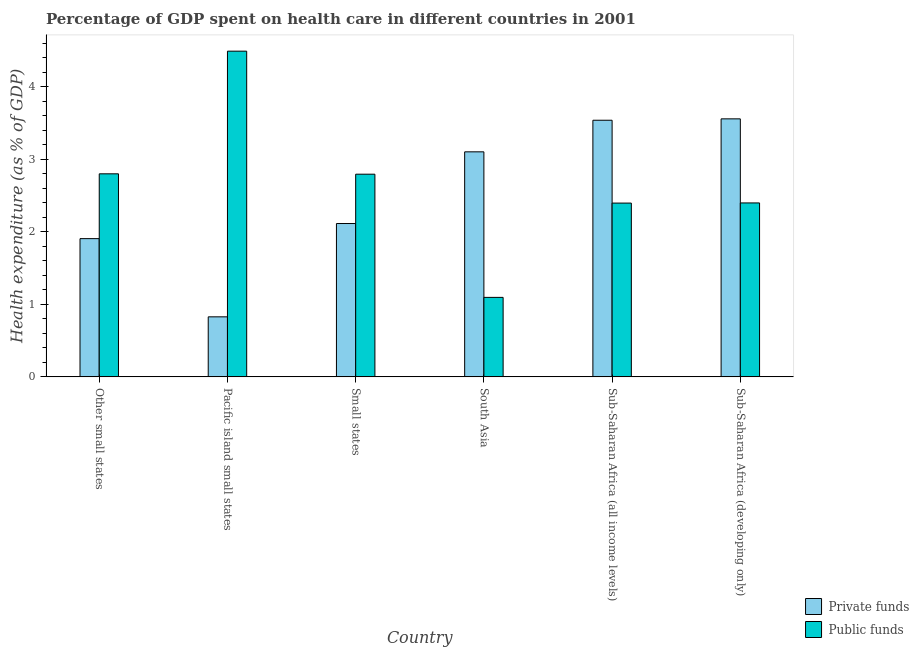How many different coloured bars are there?
Offer a very short reply. 2. How many groups of bars are there?
Your answer should be very brief. 6. Are the number of bars per tick equal to the number of legend labels?
Your answer should be compact. Yes. What is the label of the 2nd group of bars from the left?
Provide a succinct answer. Pacific island small states. In how many cases, is the number of bars for a given country not equal to the number of legend labels?
Make the answer very short. 0. What is the amount of private funds spent in healthcare in Sub-Saharan Africa (all income levels)?
Provide a succinct answer. 3.54. Across all countries, what is the maximum amount of public funds spent in healthcare?
Give a very brief answer. 4.49. Across all countries, what is the minimum amount of public funds spent in healthcare?
Your answer should be compact. 1.1. In which country was the amount of private funds spent in healthcare maximum?
Give a very brief answer. Sub-Saharan Africa (developing only). What is the total amount of private funds spent in healthcare in the graph?
Keep it short and to the point. 15.05. What is the difference between the amount of private funds spent in healthcare in Small states and that in Sub-Saharan Africa (developing only)?
Your answer should be very brief. -1.44. What is the difference between the amount of private funds spent in healthcare in Sub-Saharan Africa (all income levels) and the amount of public funds spent in healthcare in Small states?
Your answer should be very brief. 0.74. What is the average amount of public funds spent in healthcare per country?
Your answer should be compact. 2.66. What is the difference between the amount of private funds spent in healthcare and amount of public funds spent in healthcare in Sub-Saharan Africa (developing only)?
Offer a terse response. 1.16. What is the ratio of the amount of private funds spent in healthcare in Pacific island small states to that in Sub-Saharan Africa (developing only)?
Your answer should be very brief. 0.23. Is the amount of public funds spent in healthcare in Small states less than that in South Asia?
Your response must be concise. No. What is the difference between the highest and the second highest amount of public funds spent in healthcare?
Ensure brevity in your answer.  1.69. What is the difference between the highest and the lowest amount of public funds spent in healthcare?
Give a very brief answer. 3.4. In how many countries, is the amount of private funds spent in healthcare greater than the average amount of private funds spent in healthcare taken over all countries?
Ensure brevity in your answer.  3. What does the 1st bar from the left in Other small states represents?
Ensure brevity in your answer.  Private funds. What does the 2nd bar from the right in Sub-Saharan Africa (developing only) represents?
Your answer should be very brief. Private funds. How many bars are there?
Provide a succinct answer. 12. Are all the bars in the graph horizontal?
Your answer should be very brief. No. How many countries are there in the graph?
Your answer should be very brief. 6. Are the values on the major ticks of Y-axis written in scientific E-notation?
Your answer should be compact. No. How many legend labels are there?
Offer a terse response. 2. What is the title of the graph?
Give a very brief answer. Percentage of GDP spent on health care in different countries in 2001. Does "RDB nonconcessional" appear as one of the legend labels in the graph?
Provide a succinct answer. No. What is the label or title of the X-axis?
Make the answer very short. Country. What is the label or title of the Y-axis?
Your response must be concise. Health expenditure (as % of GDP). What is the Health expenditure (as % of GDP) in Private funds in Other small states?
Keep it short and to the point. 1.91. What is the Health expenditure (as % of GDP) in Public funds in Other small states?
Provide a succinct answer. 2.8. What is the Health expenditure (as % of GDP) in Private funds in Pacific island small states?
Your answer should be very brief. 0.83. What is the Health expenditure (as % of GDP) in Public funds in Pacific island small states?
Your answer should be compact. 4.49. What is the Health expenditure (as % of GDP) of Private funds in Small states?
Ensure brevity in your answer.  2.12. What is the Health expenditure (as % of GDP) in Public funds in Small states?
Offer a very short reply. 2.8. What is the Health expenditure (as % of GDP) in Private funds in South Asia?
Offer a terse response. 3.1. What is the Health expenditure (as % of GDP) in Public funds in South Asia?
Provide a succinct answer. 1.1. What is the Health expenditure (as % of GDP) of Private funds in Sub-Saharan Africa (all income levels)?
Make the answer very short. 3.54. What is the Health expenditure (as % of GDP) in Public funds in Sub-Saharan Africa (all income levels)?
Give a very brief answer. 2.4. What is the Health expenditure (as % of GDP) in Private funds in Sub-Saharan Africa (developing only)?
Your answer should be compact. 3.56. What is the Health expenditure (as % of GDP) in Public funds in Sub-Saharan Africa (developing only)?
Your answer should be very brief. 2.4. Across all countries, what is the maximum Health expenditure (as % of GDP) of Private funds?
Your answer should be very brief. 3.56. Across all countries, what is the maximum Health expenditure (as % of GDP) in Public funds?
Provide a short and direct response. 4.49. Across all countries, what is the minimum Health expenditure (as % of GDP) in Private funds?
Give a very brief answer. 0.83. Across all countries, what is the minimum Health expenditure (as % of GDP) in Public funds?
Your response must be concise. 1.1. What is the total Health expenditure (as % of GDP) of Private funds in the graph?
Your answer should be very brief. 15.05. What is the total Health expenditure (as % of GDP) of Public funds in the graph?
Offer a terse response. 15.98. What is the difference between the Health expenditure (as % of GDP) of Private funds in Other small states and that in Pacific island small states?
Your response must be concise. 1.08. What is the difference between the Health expenditure (as % of GDP) in Public funds in Other small states and that in Pacific island small states?
Your answer should be compact. -1.69. What is the difference between the Health expenditure (as % of GDP) of Private funds in Other small states and that in Small states?
Provide a succinct answer. -0.21. What is the difference between the Health expenditure (as % of GDP) in Public funds in Other small states and that in Small states?
Provide a short and direct response. 0.01. What is the difference between the Health expenditure (as % of GDP) of Private funds in Other small states and that in South Asia?
Your answer should be compact. -1.2. What is the difference between the Health expenditure (as % of GDP) in Public funds in Other small states and that in South Asia?
Offer a very short reply. 1.7. What is the difference between the Health expenditure (as % of GDP) in Private funds in Other small states and that in Sub-Saharan Africa (all income levels)?
Offer a terse response. -1.63. What is the difference between the Health expenditure (as % of GDP) of Public funds in Other small states and that in Sub-Saharan Africa (all income levels)?
Provide a succinct answer. 0.4. What is the difference between the Health expenditure (as % of GDP) of Private funds in Other small states and that in Sub-Saharan Africa (developing only)?
Provide a short and direct response. -1.65. What is the difference between the Health expenditure (as % of GDP) in Public funds in Other small states and that in Sub-Saharan Africa (developing only)?
Ensure brevity in your answer.  0.4. What is the difference between the Health expenditure (as % of GDP) in Private funds in Pacific island small states and that in Small states?
Offer a very short reply. -1.29. What is the difference between the Health expenditure (as % of GDP) in Public funds in Pacific island small states and that in Small states?
Your answer should be very brief. 1.7. What is the difference between the Health expenditure (as % of GDP) in Private funds in Pacific island small states and that in South Asia?
Give a very brief answer. -2.28. What is the difference between the Health expenditure (as % of GDP) in Public funds in Pacific island small states and that in South Asia?
Give a very brief answer. 3.4. What is the difference between the Health expenditure (as % of GDP) in Private funds in Pacific island small states and that in Sub-Saharan Africa (all income levels)?
Your response must be concise. -2.71. What is the difference between the Health expenditure (as % of GDP) in Public funds in Pacific island small states and that in Sub-Saharan Africa (all income levels)?
Your answer should be very brief. 2.1. What is the difference between the Health expenditure (as % of GDP) of Private funds in Pacific island small states and that in Sub-Saharan Africa (developing only)?
Give a very brief answer. -2.73. What is the difference between the Health expenditure (as % of GDP) in Public funds in Pacific island small states and that in Sub-Saharan Africa (developing only)?
Give a very brief answer. 2.09. What is the difference between the Health expenditure (as % of GDP) in Private funds in Small states and that in South Asia?
Make the answer very short. -0.99. What is the difference between the Health expenditure (as % of GDP) in Public funds in Small states and that in South Asia?
Your response must be concise. 1.7. What is the difference between the Health expenditure (as % of GDP) of Private funds in Small states and that in Sub-Saharan Africa (all income levels)?
Keep it short and to the point. -1.42. What is the difference between the Health expenditure (as % of GDP) in Public funds in Small states and that in Sub-Saharan Africa (all income levels)?
Make the answer very short. 0.4. What is the difference between the Health expenditure (as % of GDP) of Private funds in Small states and that in Sub-Saharan Africa (developing only)?
Keep it short and to the point. -1.44. What is the difference between the Health expenditure (as % of GDP) in Public funds in Small states and that in Sub-Saharan Africa (developing only)?
Provide a succinct answer. 0.4. What is the difference between the Health expenditure (as % of GDP) in Private funds in South Asia and that in Sub-Saharan Africa (all income levels)?
Your answer should be compact. -0.44. What is the difference between the Health expenditure (as % of GDP) of Public funds in South Asia and that in Sub-Saharan Africa (all income levels)?
Your answer should be very brief. -1.3. What is the difference between the Health expenditure (as % of GDP) in Private funds in South Asia and that in Sub-Saharan Africa (developing only)?
Ensure brevity in your answer.  -0.46. What is the difference between the Health expenditure (as % of GDP) of Public funds in South Asia and that in Sub-Saharan Africa (developing only)?
Keep it short and to the point. -1.3. What is the difference between the Health expenditure (as % of GDP) in Private funds in Sub-Saharan Africa (all income levels) and that in Sub-Saharan Africa (developing only)?
Offer a very short reply. -0.02. What is the difference between the Health expenditure (as % of GDP) of Public funds in Sub-Saharan Africa (all income levels) and that in Sub-Saharan Africa (developing only)?
Provide a short and direct response. -0. What is the difference between the Health expenditure (as % of GDP) of Private funds in Other small states and the Health expenditure (as % of GDP) of Public funds in Pacific island small states?
Keep it short and to the point. -2.59. What is the difference between the Health expenditure (as % of GDP) in Private funds in Other small states and the Health expenditure (as % of GDP) in Public funds in Small states?
Keep it short and to the point. -0.89. What is the difference between the Health expenditure (as % of GDP) of Private funds in Other small states and the Health expenditure (as % of GDP) of Public funds in South Asia?
Ensure brevity in your answer.  0.81. What is the difference between the Health expenditure (as % of GDP) in Private funds in Other small states and the Health expenditure (as % of GDP) in Public funds in Sub-Saharan Africa (all income levels)?
Your response must be concise. -0.49. What is the difference between the Health expenditure (as % of GDP) in Private funds in Other small states and the Health expenditure (as % of GDP) in Public funds in Sub-Saharan Africa (developing only)?
Provide a succinct answer. -0.49. What is the difference between the Health expenditure (as % of GDP) in Private funds in Pacific island small states and the Health expenditure (as % of GDP) in Public funds in Small states?
Keep it short and to the point. -1.97. What is the difference between the Health expenditure (as % of GDP) in Private funds in Pacific island small states and the Health expenditure (as % of GDP) in Public funds in South Asia?
Provide a succinct answer. -0.27. What is the difference between the Health expenditure (as % of GDP) in Private funds in Pacific island small states and the Health expenditure (as % of GDP) in Public funds in Sub-Saharan Africa (all income levels)?
Offer a terse response. -1.57. What is the difference between the Health expenditure (as % of GDP) of Private funds in Pacific island small states and the Health expenditure (as % of GDP) of Public funds in Sub-Saharan Africa (developing only)?
Your response must be concise. -1.57. What is the difference between the Health expenditure (as % of GDP) of Private funds in Small states and the Health expenditure (as % of GDP) of Public funds in South Asia?
Keep it short and to the point. 1.02. What is the difference between the Health expenditure (as % of GDP) in Private funds in Small states and the Health expenditure (as % of GDP) in Public funds in Sub-Saharan Africa (all income levels)?
Keep it short and to the point. -0.28. What is the difference between the Health expenditure (as % of GDP) of Private funds in Small states and the Health expenditure (as % of GDP) of Public funds in Sub-Saharan Africa (developing only)?
Ensure brevity in your answer.  -0.28. What is the difference between the Health expenditure (as % of GDP) in Private funds in South Asia and the Health expenditure (as % of GDP) in Public funds in Sub-Saharan Africa (all income levels)?
Ensure brevity in your answer.  0.71. What is the difference between the Health expenditure (as % of GDP) of Private funds in South Asia and the Health expenditure (as % of GDP) of Public funds in Sub-Saharan Africa (developing only)?
Make the answer very short. 0.7. What is the difference between the Health expenditure (as % of GDP) in Private funds in Sub-Saharan Africa (all income levels) and the Health expenditure (as % of GDP) in Public funds in Sub-Saharan Africa (developing only)?
Ensure brevity in your answer.  1.14. What is the average Health expenditure (as % of GDP) of Private funds per country?
Your answer should be compact. 2.51. What is the average Health expenditure (as % of GDP) of Public funds per country?
Your answer should be very brief. 2.66. What is the difference between the Health expenditure (as % of GDP) in Private funds and Health expenditure (as % of GDP) in Public funds in Other small states?
Offer a terse response. -0.89. What is the difference between the Health expenditure (as % of GDP) of Private funds and Health expenditure (as % of GDP) of Public funds in Pacific island small states?
Your response must be concise. -3.66. What is the difference between the Health expenditure (as % of GDP) in Private funds and Health expenditure (as % of GDP) in Public funds in Small states?
Ensure brevity in your answer.  -0.68. What is the difference between the Health expenditure (as % of GDP) of Private funds and Health expenditure (as % of GDP) of Public funds in South Asia?
Give a very brief answer. 2.01. What is the difference between the Health expenditure (as % of GDP) in Private funds and Health expenditure (as % of GDP) in Public funds in Sub-Saharan Africa (all income levels)?
Give a very brief answer. 1.14. What is the difference between the Health expenditure (as % of GDP) of Private funds and Health expenditure (as % of GDP) of Public funds in Sub-Saharan Africa (developing only)?
Ensure brevity in your answer.  1.16. What is the ratio of the Health expenditure (as % of GDP) in Private funds in Other small states to that in Pacific island small states?
Your answer should be compact. 2.3. What is the ratio of the Health expenditure (as % of GDP) of Public funds in Other small states to that in Pacific island small states?
Offer a terse response. 0.62. What is the ratio of the Health expenditure (as % of GDP) of Private funds in Other small states to that in Small states?
Your response must be concise. 0.9. What is the ratio of the Health expenditure (as % of GDP) in Private funds in Other small states to that in South Asia?
Offer a very short reply. 0.61. What is the ratio of the Health expenditure (as % of GDP) of Public funds in Other small states to that in South Asia?
Provide a succinct answer. 2.55. What is the ratio of the Health expenditure (as % of GDP) of Private funds in Other small states to that in Sub-Saharan Africa (all income levels)?
Offer a very short reply. 0.54. What is the ratio of the Health expenditure (as % of GDP) of Public funds in Other small states to that in Sub-Saharan Africa (all income levels)?
Offer a very short reply. 1.17. What is the ratio of the Health expenditure (as % of GDP) in Private funds in Other small states to that in Sub-Saharan Africa (developing only)?
Provide a succinct answer. 0.54. What is the ratio of the Health expenditure (as % of GDP) of Public funds in Other small states to that in Sub-Saharan Africa (developing only)?
Your answer should be compact. 1.17. What is the ratio of the Health expenditure (as % of GDP) of Private funds in Pacific island small states to that in Small states?
Your answer should be compact. 0.39. What is the ratio of the Health expenditure (as % of GDP) of Public funds in Pacific island small states to that in Small states?
Provide a short and direct response. 1.61. What is the ratio of the Health expenditure (as % of GDP) of Private funds in Pacific island small states to that in South Asia?
Offer a very short reply. 0.27. What is the ratio of the Health expenditure (as % of GDP) of Public funds in Pacific island small states to that in South Asia?
Provide a succinct answer. 4.1. What is the ratio of the Health expenditure (as % of GDP) of Private funds in Pacific island small states to that in Sub-Saharan Africa (all income levels)?
Offer a terse response. 0.23. What is the ratio of the Health expenditure (as % of GDP) in Public funds in Pacific island small states to that in Sub-Saharan Africa (all income levels)?
Your answer should be compact. 1.87. What is the ratio of the Health expenditure (as % of GDP) of Private funds in Pacific island small states to that in Sub-Saharan Africa (developing only)?
Make the answer very short. 0.23. What is the ratio of the Health expenditure (as % of GDP) in Public funds in Pacific island small states to that in Sub-Saharan Africa (developing only)?
Provide a short and direct response. 1.87. What is the ratio of the Health expenditure (as % of GDP) of Private funds in Small states to that in South Asia?
Make the answer very short. 0.68. What is the ratio of the Health expenditure (as % of GDP) in Public funds in Small states to that in South Asia?
Offer a terse response. 2.55. What is the ratio of the Health expenditure (as % of GDP) of Private funds in Small states to that in Sub-Saharan Africa (all income levels)?
Provide a short and direct response. 0.6. What is the ratio of the Health expenditure (as % of GDP) of Public funds in Small states to that in Sub-Saharan Africa (all income levels)?
Your response must be concise. 1.17. What is the ratio of the Health expenditure (as % of GDP) of Private funds in Small states to that in Sub-Saharan Africa (developing only)?
Your response must be concise. 0.59. What is the ratio of the Health expenditure (as % of GDP) in Public funds in Small states to that in Sub-Saharan Africa (developing only)?
Keep it short and to the point. 1.17. What is the ratio of the Health expenditure (as % of GDP) of Private funds in South Asia to that in Sub-Saharan Africa (all income levels)?
Your answer should be compact. 0.88. What is the ratio of the Health expenditure (as % of GDP) in Public funds in South Asia to that in Sub-Saharan Africa (all income levels)?
Give a very brief answer. 0.46. What is the ratio of the Health expenditure (as % of GDP) in Private funds in South Asia to that in Sub-Saharan Africa (developing only)?
Give a very brief answer. 0.87. What is the ratio of the Health expenditure (as % of GDP) in Public funds in South Asia to that in Sub-Saharan Africa (developing only)?
Give a very brief answer. 0.46. What is the ratio of the Health expenditure (as % of GDP) in Private funds in Sub-Saharan Africa (all income levels) to that in Sub-Saharan Africa (developing only)?
Keep it short and to the point. 0.99. What is the ratio of the Health expenditure (as % of GDP) of Public funds in Sub-Saharan Africa (all income levels) to that in Sub-Saharan Africa (developing only)?
Your answer should be compact. 1. What is the difference between the highest and the second highest Health expenditure (as % of GDP) in Private funds?
Give a very brief answer. 0.02. What is the difference between the highest and the second highest Health expenditure (as % of GDP) of Public funds?
Make the answer very short. 1.69. What is the difference between the highest and the lowest Health expenditure (as % of GDP) of Private funds?
Your answer should be compact. 2.73. What is the difference between the highest and the lowest Health expenditure (as % of GDP) of Public funds?
Your answer should be compact. 3.4. 